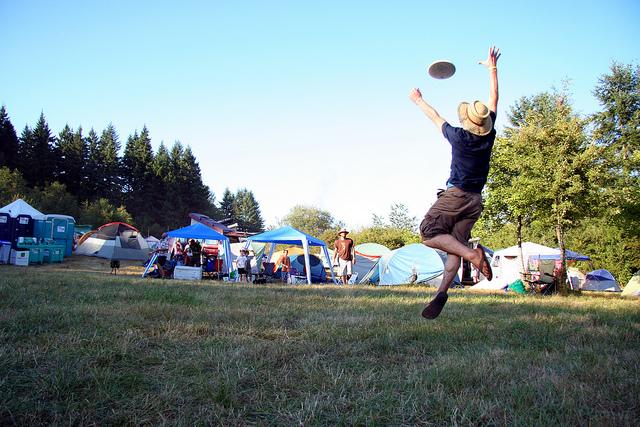What color is the man's shirt?
Short answer required. Blue. Where is sun protection?
Answer briefly. On his head. What is the person catching?
Write a very short answer. Frisbee. 